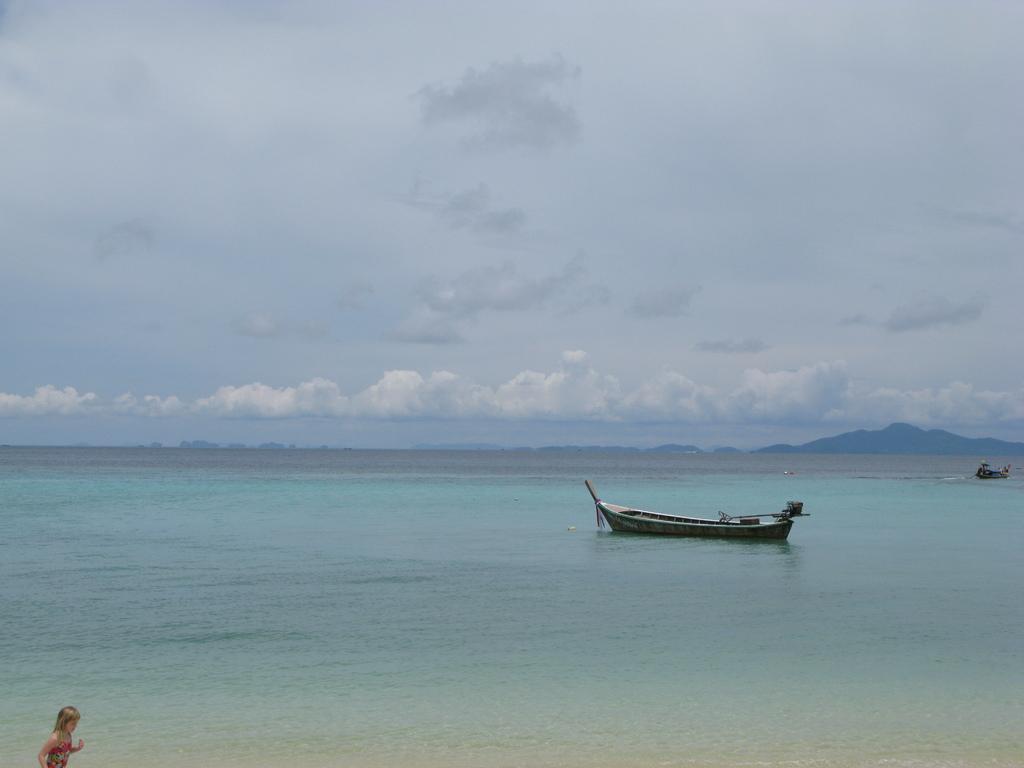Describe this image in one or two sentences. In this image I can see boat in the water. Background I can see sky in white and blue color, in front I can see a person wearing red color dress. 